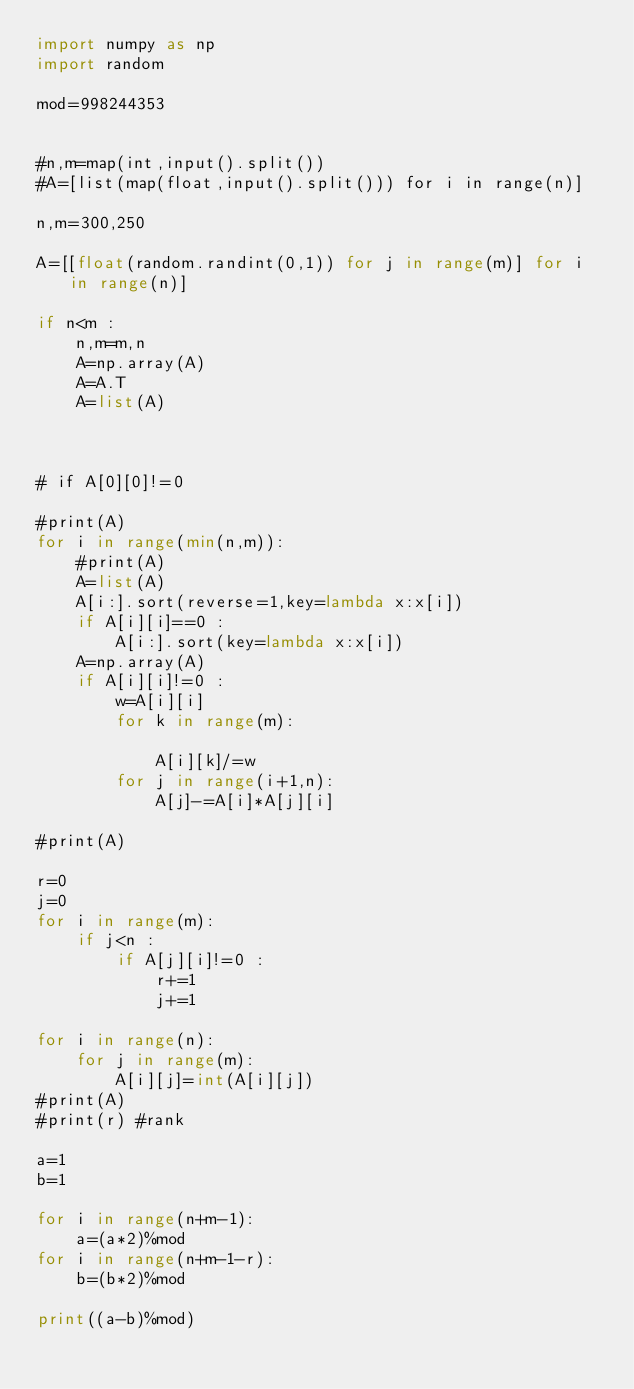Convert code to text. <code><loc_0><loc_0><loc_500><loc_500><_Python_>import numpy as np
import random

mod=998244353


#n,m=map(int,input().split())
#A=[list(map(float,input().split())) for i in range(n)]

n,m=300,250

A=[[float(random.randint(0,1)) for j in range(m)] for i in range(n)]

if n<m :
    n,m=m,n
    A=np.array(A)
    A=A.T
    A=list(A)



# if A[0][0]!=0

#print(A)
for i in range(min(n,m)):
    #print(A)
    A=list(A)
    A[i:].sort(reverse=1,key=lambda x:x[i])
    if A[i][i]==0 :
        A[i:].sort(key=lambda x:x[i])
    A=np.array(A)
    if A[i][i]!=0 :
        w=A[i][i]
        for k in range(m):
            
            A[i][k]/=w
        for j in range(i+1,n):
            A[j]-=A[i]*A[j][i]

#print(A)

r=0
j=0
for i in range(m):
    if j<n :
        if A[j][i]!=0 :
            r+=1
            j+=1

for i in range(n):
    for j in range(m):
        A[i][j]=int(A[i][j])
#print(A)
#print(r) #rank

a=1
b=1

for i in range(n+m-1):
    a=(a*2)%mod
for i in range(n+m-1-r):
    b=(b*2)%mod

print((a-b)%mod)
</code> 